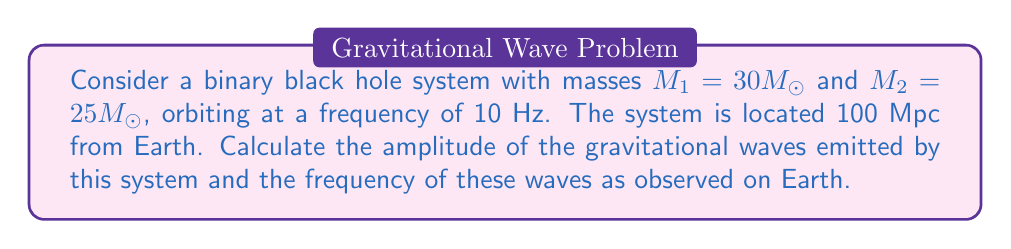Could you help me with this problem? Let's approach this step-by-step:

1) The amplitude of gravitational waves from a binary system is given by:

   $$h = \frac{4(GM_c)^{5/3}}{c^4r}(\pi f)^{2/3}$$

   Where:
   - $G$ is the gravitational constant
   - $M_c$ is the chirp mass
   - $c$ is the speed of light
   - $r$ is the distance to the source
   - $f$ is the gravitational wave frequency

2) First, we need to calculate the chirp mass $M_c$:

   $$M_c = \frac{(M_1M_2)^{3/5}}{(M_1+M_2)^{1/5}}$$

   $$M_c = \frac{(30M_\odot \cdot 25M_\odot)^{3/5}}{(30M_\odot+25M_\odot)^{1/5}} \approx 23.9M_\odot$$

3) The gravitational wave frequency is twice the orbital frequency:

   $$f_{GW} = 2f_{orbital} = 2 \cdot 10 \text{ Hz} = 20 \text{ Hz}$$

4) Now we can calculate the amplitude:

   $$h = \frac{4(G \cdot 23.9M_\odot)^{5/3}}{c^4 \cdot 100\text{ Mpc}}(\pi \cdot 20\text{ Hz})^{2/3}$$

5) Plugging in the values (and converting units appropriately):

   $$h \approx 1.3 \times 10^{-22}$$

Thus, the amplitude of the gravitational waves is approximately $1.3 \times 10^{-22}$, and the frequency is 20 Hz.
Answer: Amplitude: $1.3 \times 10^{-22}$, Frequency: 20 Hz 